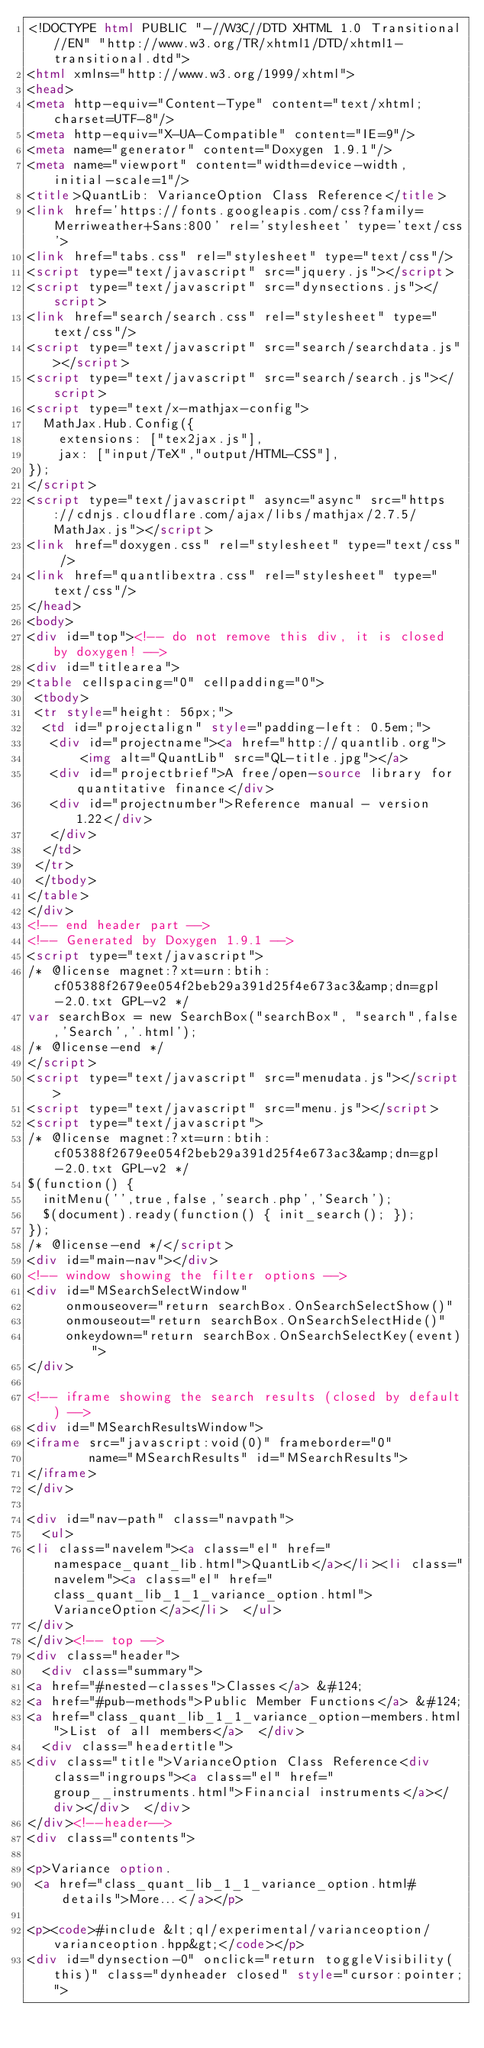<code> <loc_0><loc_0><loc_500><loc_500><_HTML_><!DOCTYPE html PUBLIC "-//W3C//DTD XHTML 1.0 Transitional//EN" "http://www.w3.org/TR/xhtml1/DTD/xhtml1-transitional.dtd">
<html xmlns="http://www.w3.org/1999/xhtml">
<head>
<meta http-equiv="Content-Type" content="text/xhtml;charset=UTF-8"/>
<meta http-equiv="X-UA-Compatible" content="IE=9"/>
<meta name="generator" content="Doxygen 1.9.1"/>
<meta name="viewport" content="width=device-width, initial-scale=1"/>
<title>QuantLib: VarianceOption Class Reference</title>
<link href='https://fonts.googleapis.com/css?family=Merriweather+Sans:800' rel='stylesheet' type='text/css'>
<link href="tabs.css" rel="stylesheet" type="text/css"/>
<script type="text/javascript" src="jquery.js"></script>
<script type="text/javascript" src="dynsections.js"></script>
<link href="search/search.css" rel="stylesheet" type="text/css"/>
<script type="text/javascript" src="search/searchdata.js"></script>
<script type="text/javascript" src="search/search.js"></script>
<script type="text/x-mathjax-config">
  MathJax.Hub.Config({
    extensions: ["tex2jax.js"],
    jax: ["input/TeX","output/HTML-CSS"],
});
</script>
<script type="text/javascript" async="async" src="https://cdnjs.cloudflare.com/ajax/libs/mathjax/2.7.5/MathJax.js"></script>
<link href="doxygen.css" rel="stylesheet" type="text/css" />
<link href="quantlibextra.css" rel="stylesheet" type="text/css"/>
</head>
<body>
<div id="top"><!-- do not remove this div, it is closed by doxygen! -->
<div id="titlearea">
<table cellspacing="0" cellpadding="0">
 <tbody>
 <tr style="height: 56px;">
  <td id="projectalign" style="padding-left: 0.5em;">
   <div id="projectname"><a href="http://quantlib.org">
       <img alt="QuantLib" src="QL-title.jpg"></a>
   <div id="projectbrief">A free/open-source library for quantitative finance</div>
   <div id="projectnumber">Reference manual - version 1.22</div>
   </div>
  </td>
 </tr>
 </tbody>
</table>
</div>
<!-- end header part -->
<!-- Generated by Doxygen 1.9.1 -->
<script type="text/javascript">
/* @license magnet:?xt=urn:btih:cf05388f2679ee054f2beb29a391d25f4e673ac3&amp;dn=gpl-2.0.txt GPL-v2 */
var searchBox = new SearchBox("searchBox", "search",false,'Search','.html');
/* @license-end */
</script>
<script type="text/javascript" src="menudata.js"></script>
<script type="text/javascript" src="menu.js"></script>
<script type="text/javascript">
/* @license magnet:?xt=urn:btih:cf05388f2679ee054f2beb29a391d25f4e673ac3&amp;dn=gpl-2.0.txt GPL-v2 */
$(function() {
  initMenu('',true,false,'search.php','Search');
  $(document).ready(function() { init_search(); });
});
/* @license-end */</script>
<div id="main-nav"></div>
<!-- window showing the filter options -->
<div id="MSearchSelectWindow"
     onmouseover="return searchBox.OnSearchSelectShow()"
     onmouseout="return searchBox.OnSearchSelectHide()"
     onkeydown="return searchBox.OnSearchSelectKey(event)">
</div>

<!-- iframe showing the search results (closed by default) -->
<div id="MSearchResultsWindow">
<iframe src="javascript:void(0)" frameborder="0" 
        name="MSearchResults" id="MSearchResults">
</iframe>
</div>

<div id="nav-path" class="navpath">
  <ul>
<li class="navelem"><a class="el" href="namespace_quant_lib.html">QuantLib</a></li><li class="navelem"><a class="el" href="class_quant_lib_1_1_variance_option.html">VarianceOption</a></li>  </ul>
</div>
</div><!-- top -->
<div class="header">
  <div class="summary">
<a href="#nested-classes">Classes</a> &#124;
<a href="#pub-methods">Public Member Functions</a> &#124;
<a href="class_quant_lib_1_1_variance_option-members.html">List of all members</a>  </div>
  <div class="headertitle">
<div class="title">VarianceOption Class Reference<div class="ingroups"><a class="el" href="group__instruments.html">Financial instruments</a></div></div>  </div>
</div><!--header-->
<div class="contents">

<p>Variance option.  
 <a href="class_quant_lib_1_1_variance_option.html#details">More...</a></p>

<p><code>#include &lt;ql/experimental/varianceoption/varianceoption.hpp&gt;</code></p>
<div id="dynsection-0" onclick="return toggleVisibility(this)" class="dynheader closed" style="cursor:pointer;"></code> 